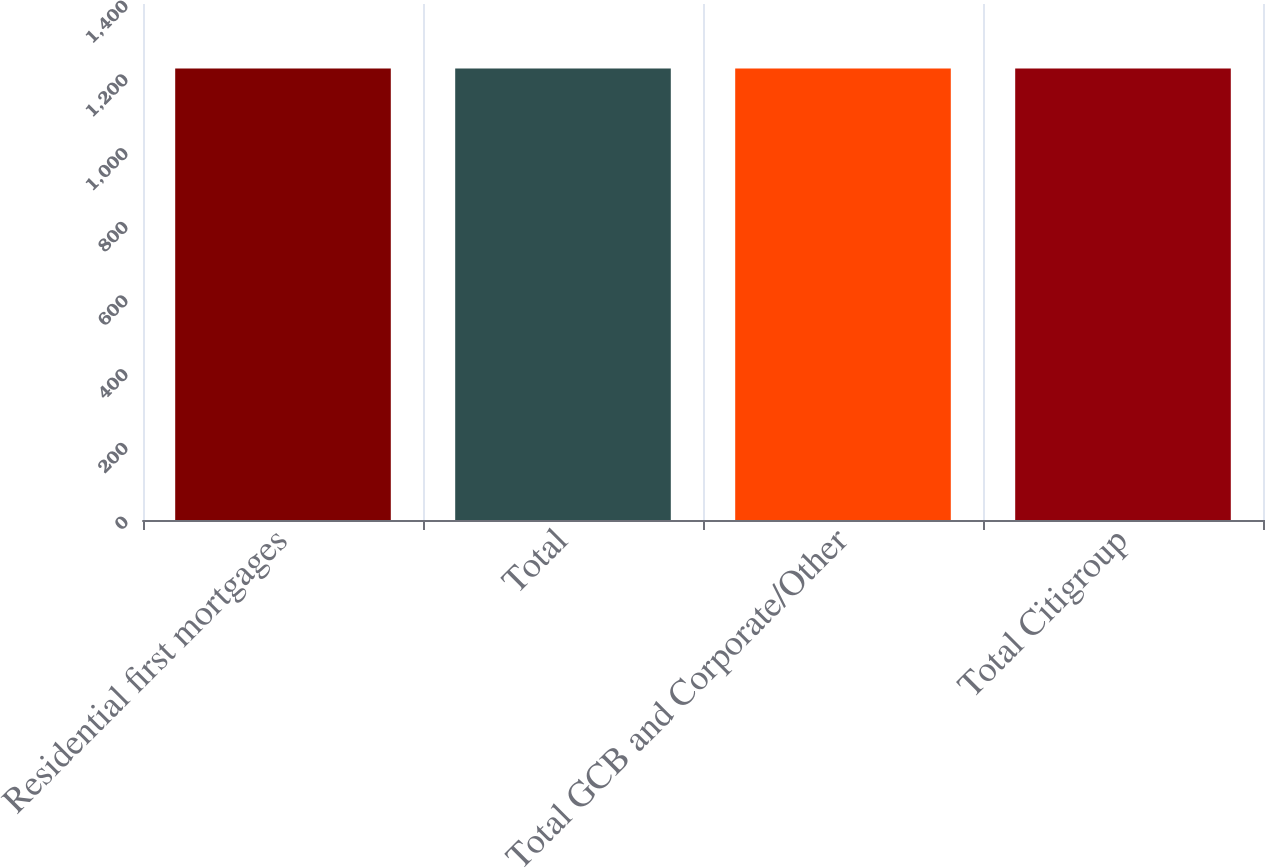Convert chart to OTSL. <chart><loc_0><loc_0><loc_500><loc_500><bar_chart><fcel>Residential first mortgages<fcel>Total<fcel>Total GCB and Corporate/Other<fcel>Total Citigroup<nl><fcel>1225<fcel>1225.1<fcel>1225.2<fcel>1225.3<nl></chart> 